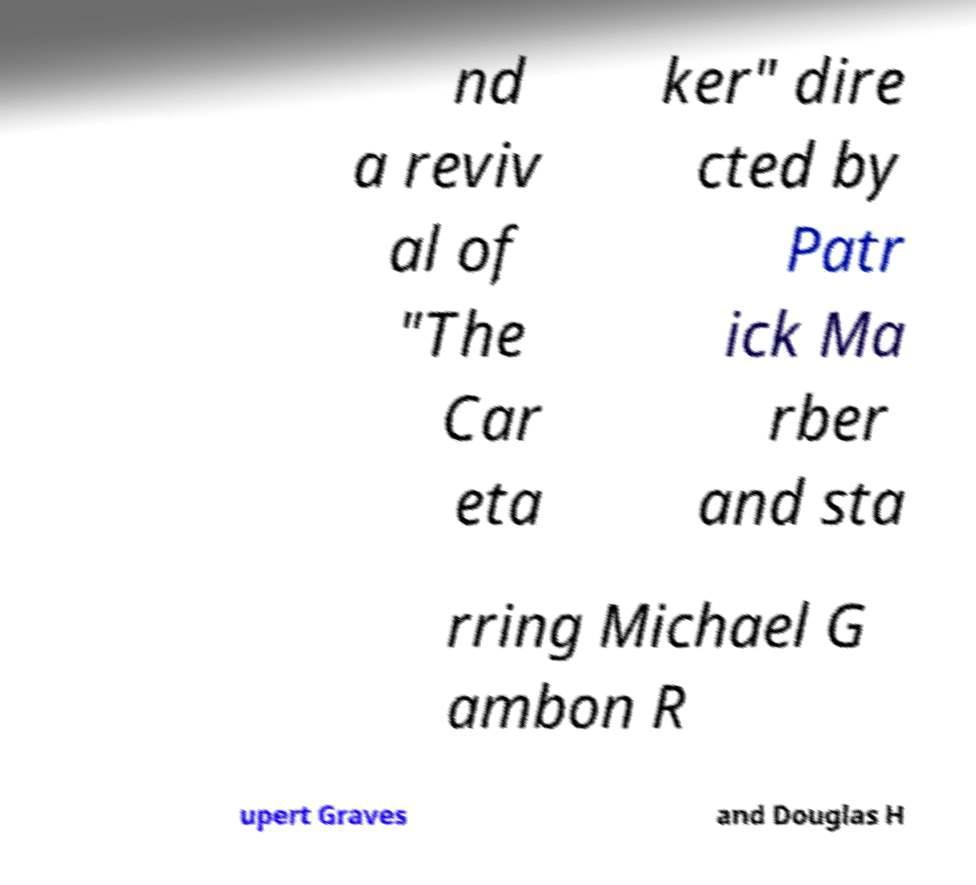Can you accurately transcribe the text from the provided image for me? nd a reviv al of "The Car eta ker" dire cted by Patr ick Ma rber and sta rring Michael G ambon R upert Graves and Douglas H 